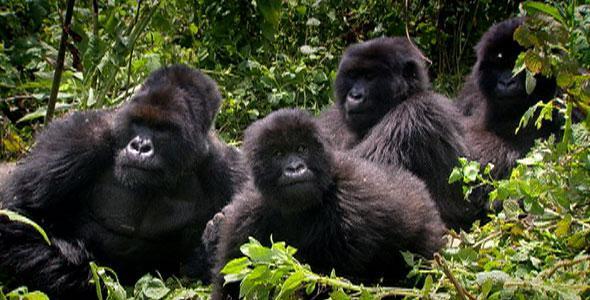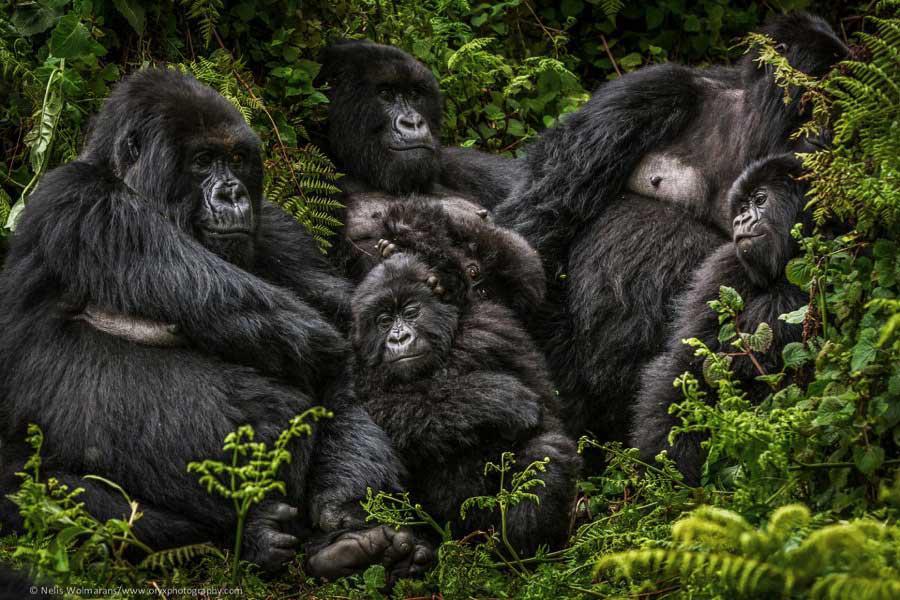The first image is the image on the left, the second image is the image on the right. Assess this claim about the two images: "One of the images shows at least one gorilla standing on its hands.". Correct or not? Answer yes or no. No. The first image is the image on the left, the second image is the image on the right. Given the left and right images, does the statement "Right image shows one foreground family-type gorilla group, which includes young gorillas." hold true? Answer yes or no. Yes. 